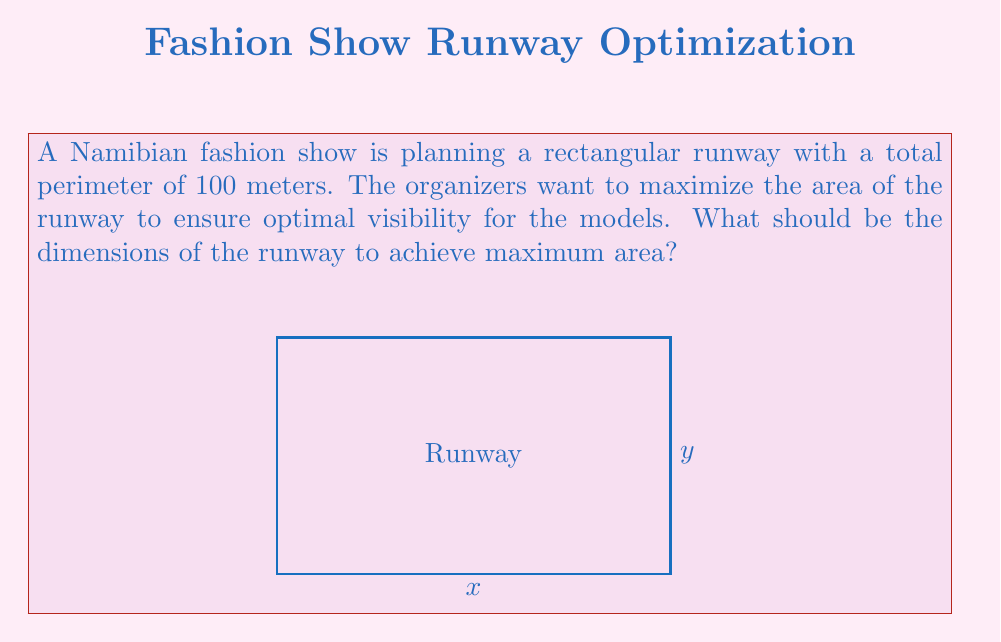Could you help me with this problem? Let's approach this step-by-step:

1) Let the width of the runway be $x$ and the length be $y$.

2) Given that the perimeter is 100 meters, we can write:
   $$2x + 2y = 100$$

3) Solving for $y$:
   $$y = 50 - x$$

4) The area of the runway is given by $A = xy$. Substituting $y$:
   $$A = x(50-x) = 50x - x^2$$

5) To find the maximum area, we need to find where the derivative of $A$ with respect to $x$ is zero:
   $$\frac{dA}{dx} = 50 - 2x$$

6) Setting this equal to zero:
   $$50 - 2x = 0$$
   $$2x = 50$$
   $$x = 25$$

7) Since the second derivative $\frac{d^2A}{dx^2} = -2$ is negative, this critical point is a maximum.

8) With $x = 25$, we can find $y$:
   $$y = 50 - 25 = 25$$

9) Therefore, the optimal dimensions are 25m × 25m, forming a square.

10) We can verify that this satisfies the perimeter condition:
    $$2(25) + 2(25) = 100$$
Answer: 25m × 25m 